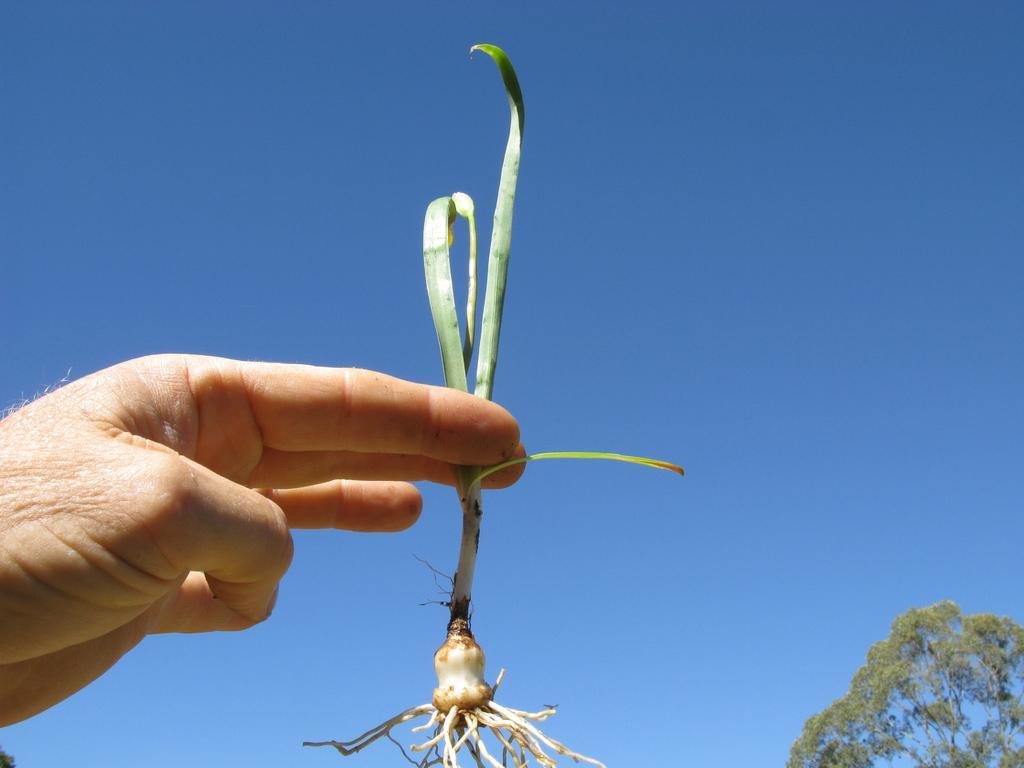How would you summarize this image in a sentence or two? In this image, we can see a human hand holding a plant. Here we can see roots. Right side bottom corner, there is a tree. Background we can see a clear sky. 